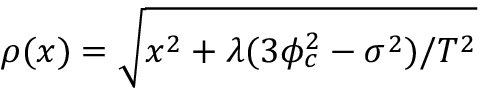Convert formula to latex. <formula><loc_0><loc_0><loc_500><loc_500>\rho ( x ) = \sqrt { x ^ { 2 } + \lambda ( 3 \phi _ { c } ^ { 2 } - \sigma ^ { 2 } ) / T ^ { 2 } }</formula> 